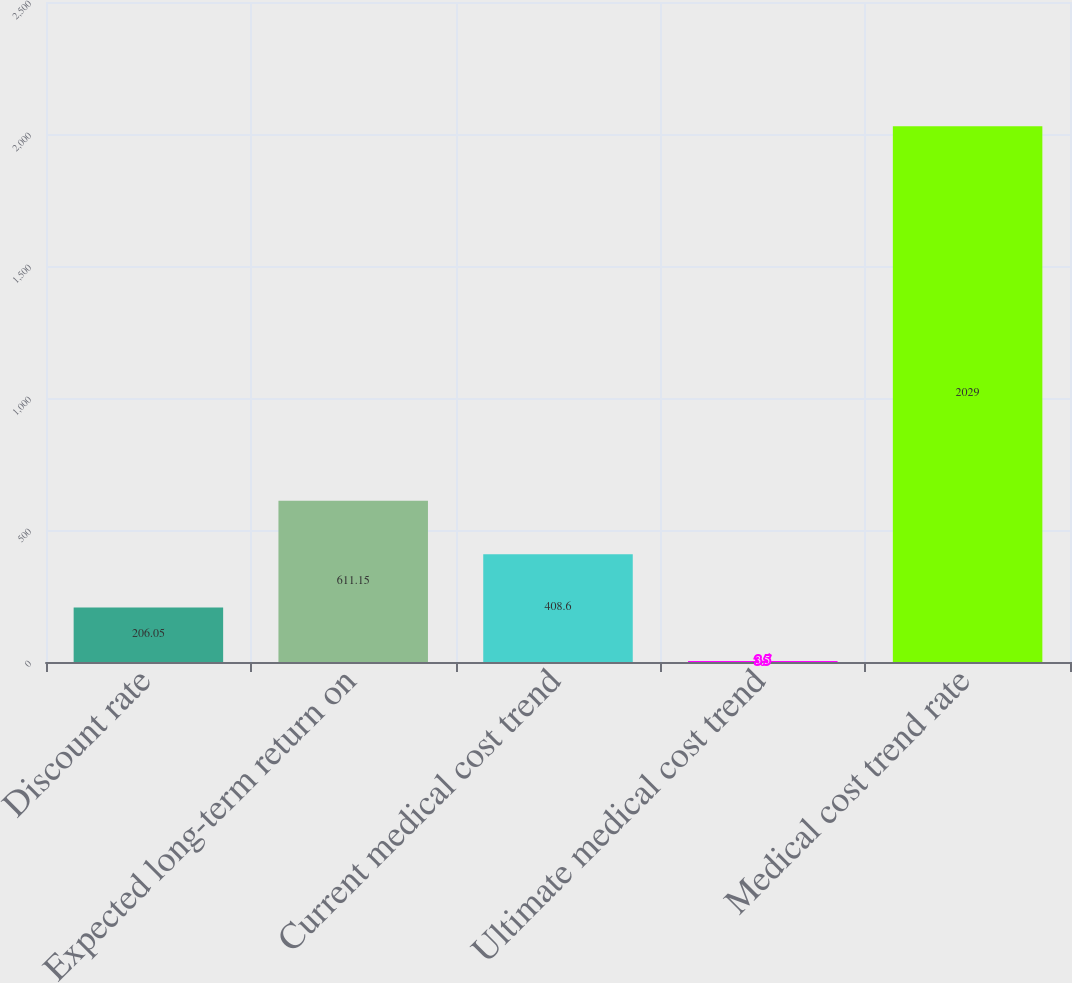Convert chart to OTSL. <chart><loc_0><loc_0><loc_500><loc_500><bar_chart><fcel>Discount rate<fcel>Expected long-term return on<fcel>Current medical cost trend<fcel>Ultimate medical cost trend<fcel>Medical cost trend rate<nl><fcel>206.05<fcel>611.15<fcel>408.6<fcel>3.5<fcel>2029<nl></chart> 